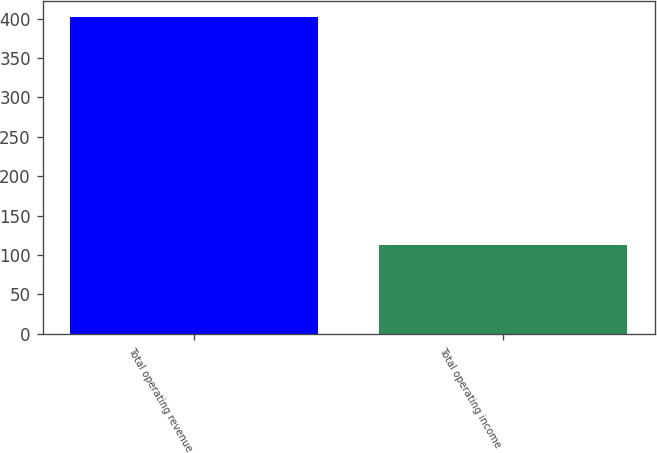Convert chart to OTSL. <chart><loc_0><loc_0><loc_500><loc_500><bar_chart><fcel>Total operating revenue<fcel>Total operating income<nl><fcel>402.6<fcel>112.4<nl></chart> 